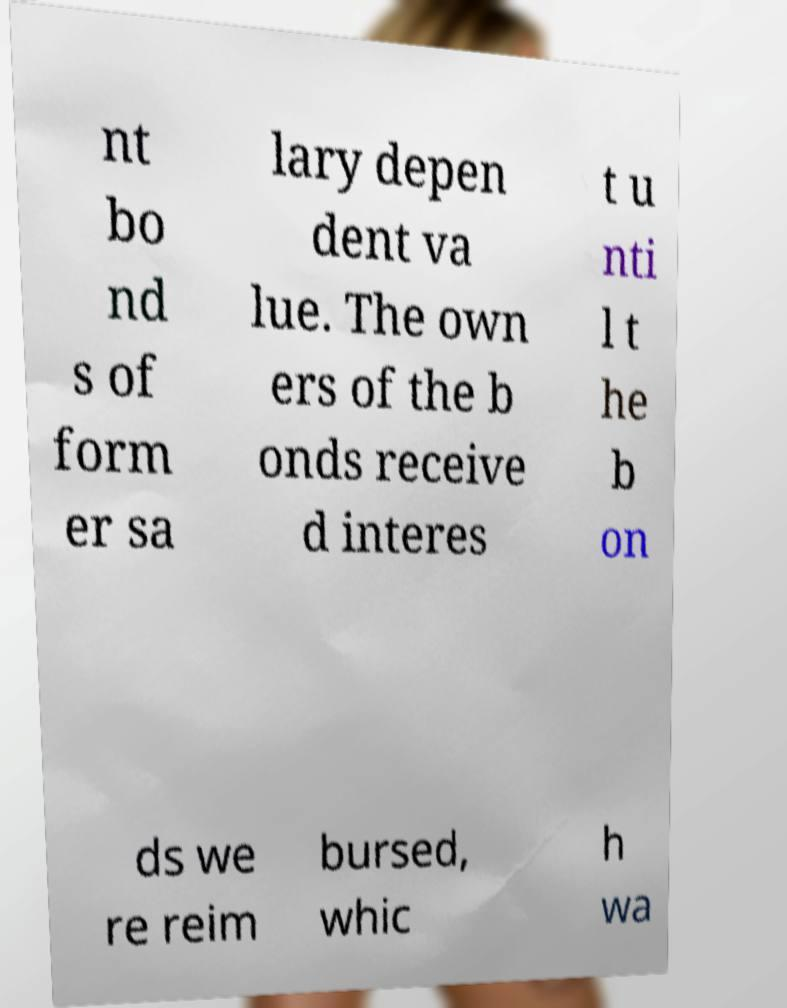For documentation purposes, I need the text within this image transcribed. Could you provide that? nt bo nd s of form er sa lary depen dent va lue. The own ers of the b onds receive d interes t u nti l t he b on ds we re reim bursed, whic h wa 